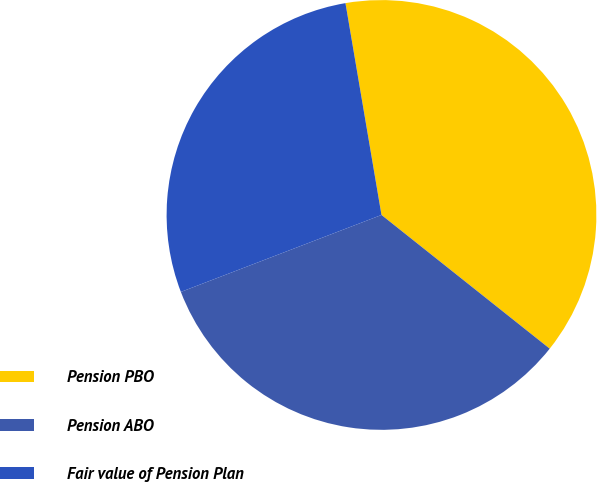Convert chart to OTSL. <chart><loc_0><loc_0><loc_500><loc_500><pie_chart><fcel>Pension PBO<fcel>Pension ABO<fcel>Fair value of Pension Plan<nl><fcel>38.37%<fcel>33.48%<fcel>28.15%<nl></chart> 